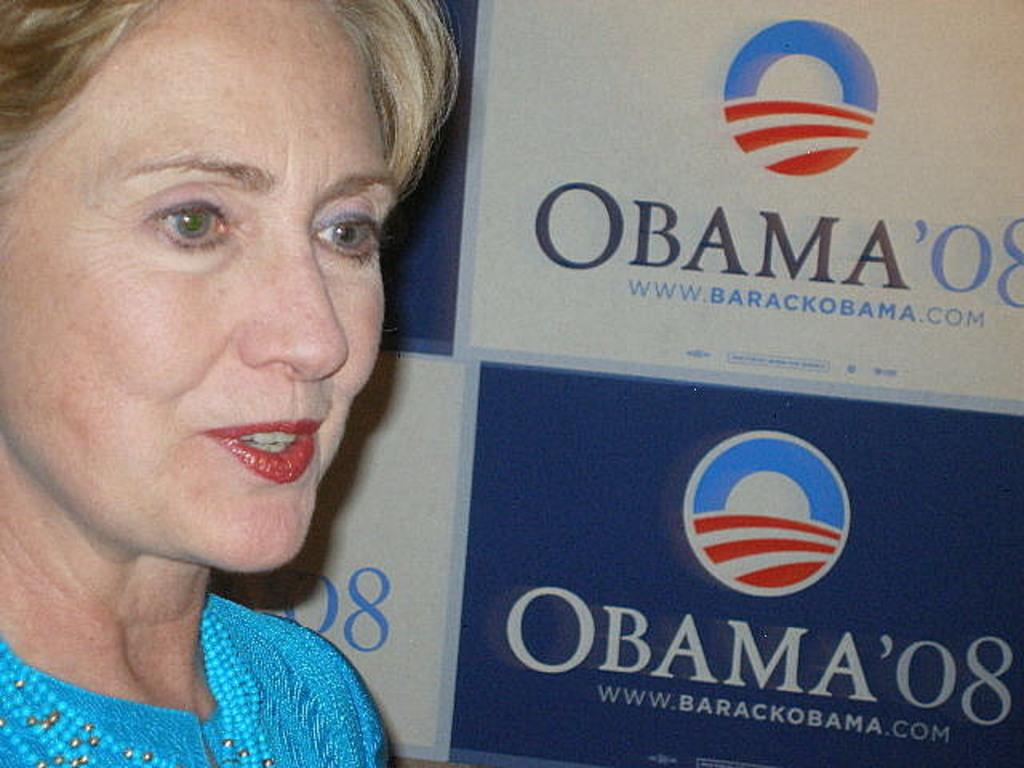What is the main subject of the image? There is a person standing in the image. What else can be seen in the image besides the person? There is a banner with text in the image. Can you describe the banner in more detail? Yes, there is a logo on the banner. Can you tell me how many snails are crawling on the person's shoes in the image? There are no snails present in the image, so it is not possible to determine how many might be crawling on the person's shoes. 